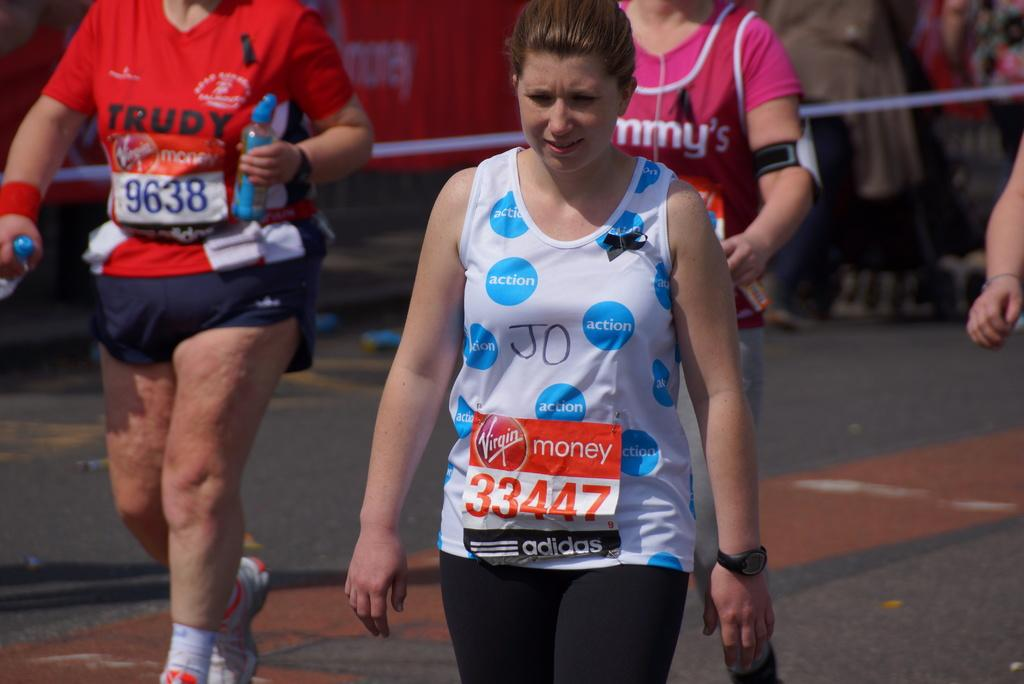<image>
Relay a brief, clear account of the picture shown. the sponsors of the event are Virgin and adidas 